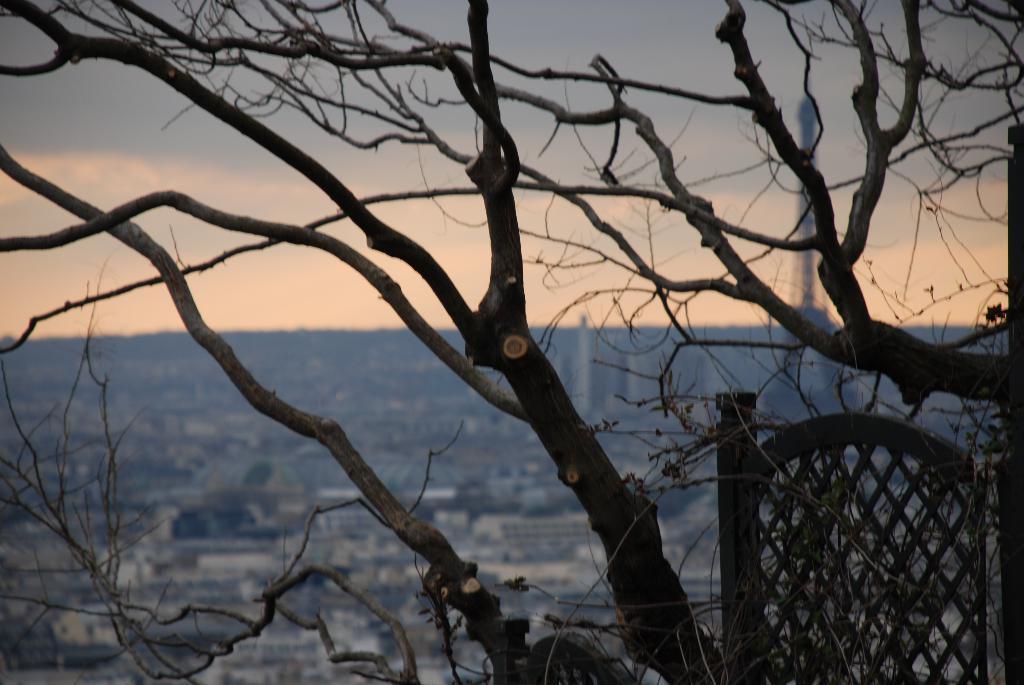Can you describe this image briefly? In this picture there are some dried trees. In the background there some buildings and a tower on the right side. In the background I can observe a sky. 